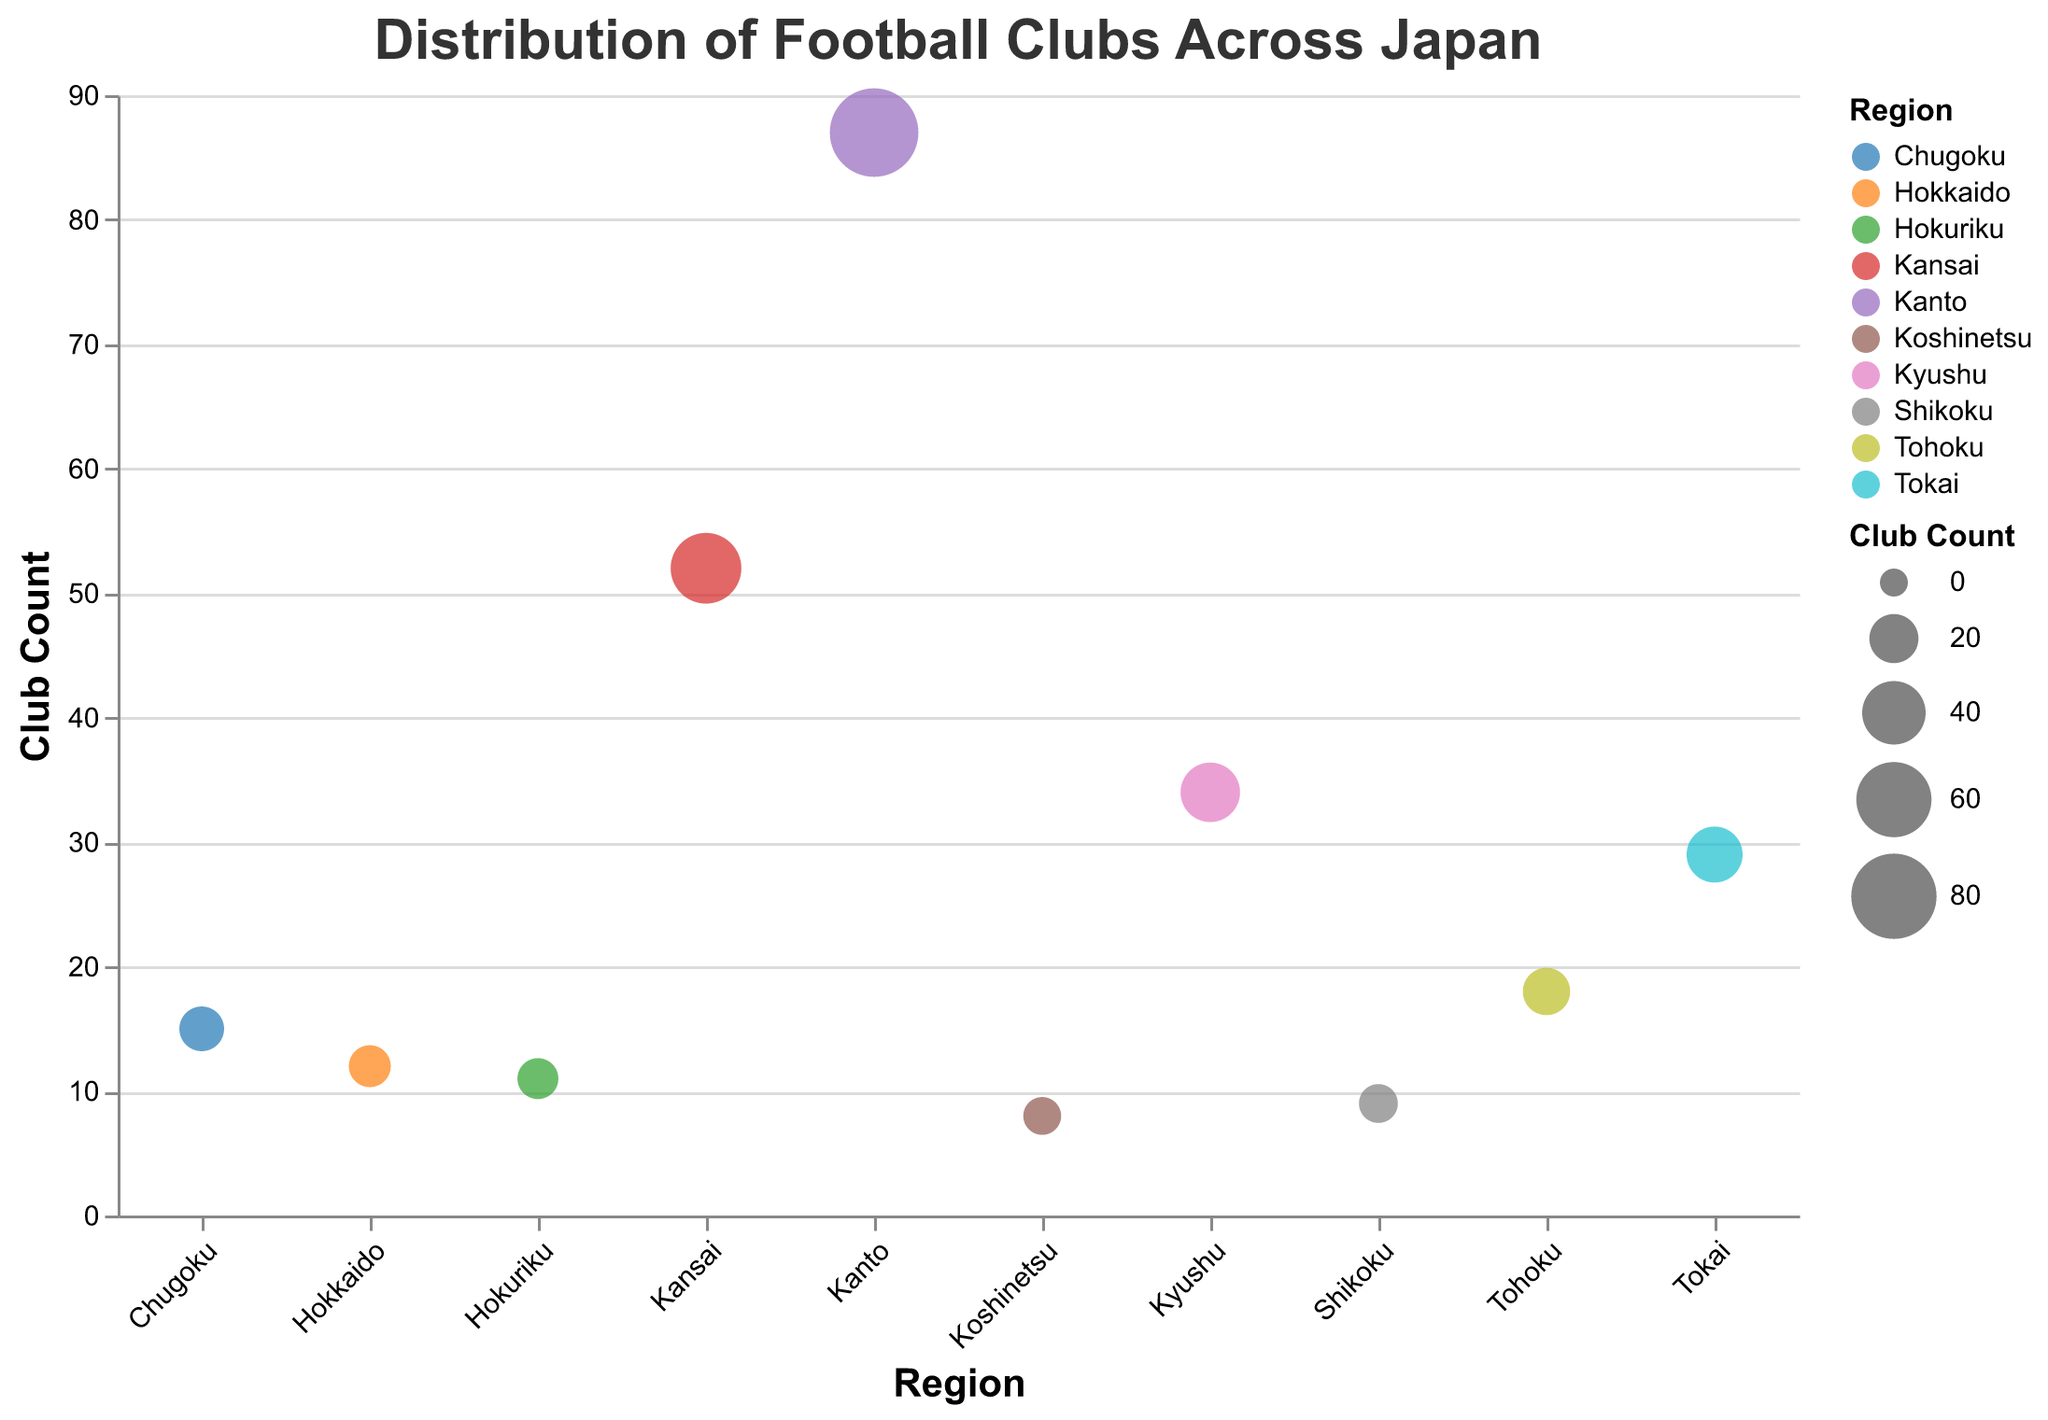What is the title of the figure? The title is displayed at the top of the figure and reads "Distribution of Football Clubs Across Japan".
Answer: Distribution of Football Clubs Across Japan Which region has the highest number of football clubs? The region with the largest circle, indicating the highest club count, is labeled "Kanto".
Answer: Kanto What is the notable club in the Kansai region? The tooltip or annotation associated with the Kansai region specifies the notable club.
Answer: Gamba Osaka How many football clubs are there in the Koshinetsu region? By looking at the circle size and the tooltip value associated with the Koshinetsu region, there are 8 clubs.
Answer: 8 Compare the number of football clubs in Kanto and Chugoku. The Kanto region has 87 clubs, and Chugoku has 15 clubs, so Kanto has far more clubs than Chugoku.
Answer: Kanto has more clubs How many regions have more than 30 football clubs? There are three regions with more than 30 clubs: Kanto, Kansai, and Kyushu (87, 52, and 34 respectively).
Answer: 3 What would be the average number of football clubs per region? Add up all the club counts (87 + 52 + 34 + 29 + 12 + 18 + 15 + 9 + 11 + 8 = 275) and divide by the number of regions (10).
Answer: 27.5 Which region has the least number of football clubs? The smallest circle, indicating the fewest clubs, is associated with the Koshinetsu region.
Answer: Koshinetsu What is the difference in club count between Kyushu and Hokuriku? Kyushu has 34 clubs and Hokuriku has 11 clubs, so the difference is 34 - 11.
Answer: 23 Are there any regions with an equal number of football clubs? By examining the club counts, no two regions have the same number of clubs.
Answer: No 